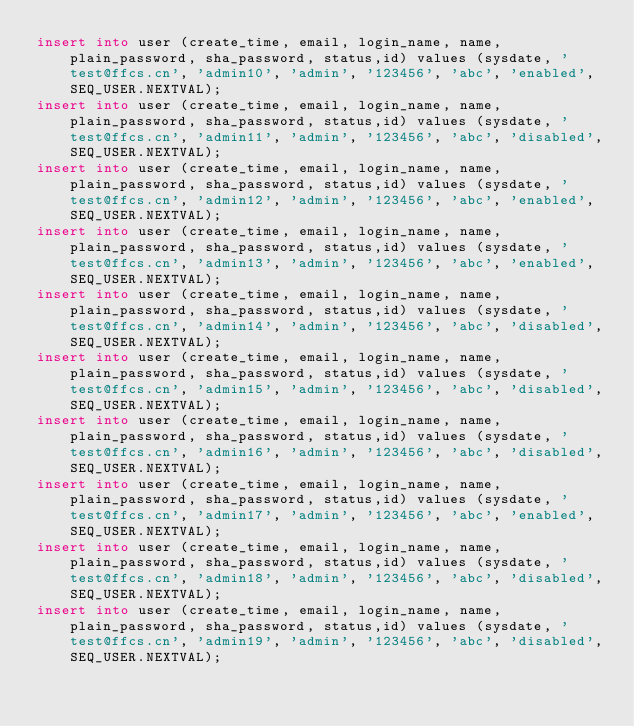Convert code to text. <code><loc_0><loc_0><loc_500><loc_500><_SQL_>insert into user (create_time, email, login_name, name, plain_password, sha_password, status,id) values (sysdate, 'test@ffcs.cn', 'admin10', 'admin', '123456', 'abc', 'enabled',SEQ_USER.NEXTVAL);
insert into user (create_time, email, login_name, name, plain_password, sha_password, status,id) values (sysdate, 'test@ffcs.cn', 'admin11', 'admin', '123456', 'abc', 'disabled',SEQ_USER.NEXTVAL);
insert into user (create_time, email, login_name, name, plain_password, sha_password, status,id) values (sysdate, 'test@ffcs.cn', 'admin12', 'admin', '123456', 'abc', 'enabled',SEQ_USER.NEXTVAL);
insert into user (create_time, email, login_name, name, plain_password, sha_password, status,id) values (sysdate, 'test@ffcs.cn', 'admin13', 'admin', '123456', 'abc', 'enabled',SEQ_USER.NEXTVAL);
insert into user (create_time, email, login_name, name, plain_password, sha_password, status,id) values (sysdate, 'test@ffcs.cn', 'admin14', 'admin', '123456', 'abc', 'disabled',SEQ_USER.NEXTVAL);
insert into user (create_time, email, login_name, name, plain_password, sha_password, status,id) values (sysdate, 'test@ffcs.cn', 'admin15', 'admin', '123456', 'abc', 'disabled',SEQ_USER.NEXTVAL);
insert into user (create_time, email, login_name, name, plain_password, sha_password, status,id) values (sysdate, 'test@ffcs.cn', 'admin16', 'admin', '123456', 'abc', 'disabled',SEQ_USER.NEXTVAL);
insert into user (create_time, email, login_name, name, plain_password, sha_password, status,id) values (sysdate, 'test@ffcs.cn', 'admin17', 'admin', '123456', 'abc', 'enabled',SEQ_USER.NEXTVAL);
insert into user (create_time, email, login_name, name, plain_password, sha_password, status,id) values (sysdate, 'test@ffcs.cn', 'admin18', 'admin', '123456', 'abc', 'disabled',SEQ_USER.NEXTVAL);
insert into user (create_time, email, login_name, name, plain_password, sha_password, status,id) values (sysdate, 'test@ffcs.cn', 'admin19', 'admin', '123456', 'abc', 'disabled',SEQ_USER.NEXTVAL);</code> 